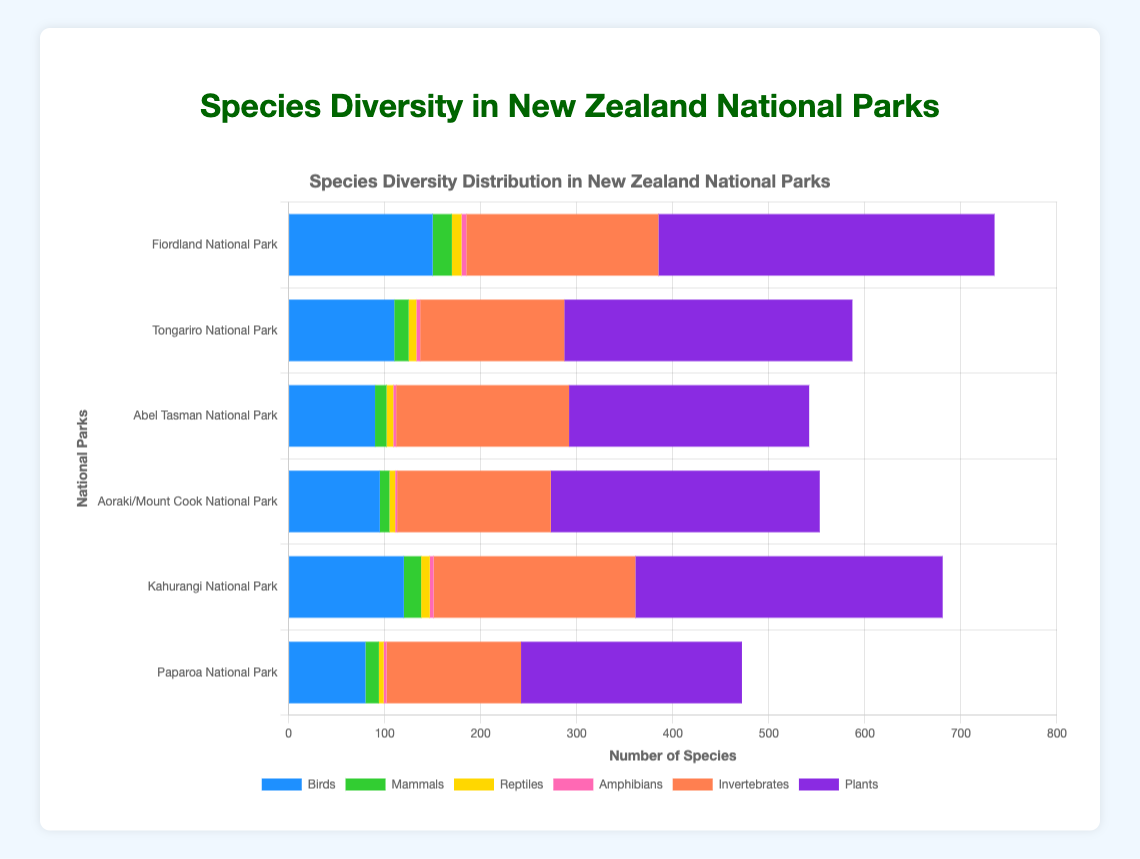Which national park has the highest number of plant species? First, look at the bars representing plant species for each national park. Find the longest bar in the "Plants" category. Fiordland National Park has the highest bar with 350 species.
Answer: Fiordland National Park Compare the number of bird species between Fiordland National Park and Paparoa National Park. Which one has more and by how much? Fiordland National Park has 150 bird species, while Paparoa National Park has 80. Subtracting these gives 150 - 80 = 70. Fiordland National Park has 70 more bird species than Paparoa National Park.
Answer: Fiordland National Park by 70 What is the total number of species (all categories) in Tongariro National Park? Sum the species in all categories for Tongariro: 110 (birds) + 15 (mammals) + 8 (reptiles) + 4 (amphibians) + 150 (invertebrates) + 300 (plants) = 587.
Answer: 587 Which national park has the lowest number of amphibian species? Look at the bars representing amphibian species and find the shortest one across all parks. Aoraki/Mount Cook National Park has the shortest bar with 2 species.
Answer: Aoraki/Mount Cook National Park How does the number of mammal species in Kahurangi National Park compare to that in Aoraki/Mount Cook National Park? Kahurangi National Park has 18 mammal species, while Aoraki/Mount Cook National Park has 10. Kahurangi has 8 more species than Aoraki/Mount Cook.
Answer: Kahurangi has 8 more What is the average number of invertebrate species across all the national parks? Sum all invertebrate species and divide by the number of parks: (200 + 150 + 180 + 160 + 210 + 140) / 6 = 1040 / 6 ≈ 173.3.
Answer: Approximately 173.3 Examine the plant species diversity: which national park has the second-highest number of plant species? First, identify the longest plant bar (Fiordland with 350). The second longest is Kahurangi National Park with 320 plant species.
Answer: Kahurangi National Park Compare the combined total number of reptile and amphibian species in Abel Tasman National Park with the total in Paparoa National Park. Which one has more and by how much? Abel Tasman: 7 (reptiles) + 3 (amphibians) = 10. Paparoa: 5 (reptiles) + 3 (amphibians) = 8. Abel Tasman has 2 more species than Paparoa.
Answer: Abel Tasman by 2 Which park has a more balanced distribution of species, considering mammals and amphibians as indicators? Compare the relative size of bars for mammals and amphibians in each park. Fiordland looks more balanced with 20 mammals and 5 amphibians compared to bigger discrepancies in other parks.
Answer: Fiordland National Park 